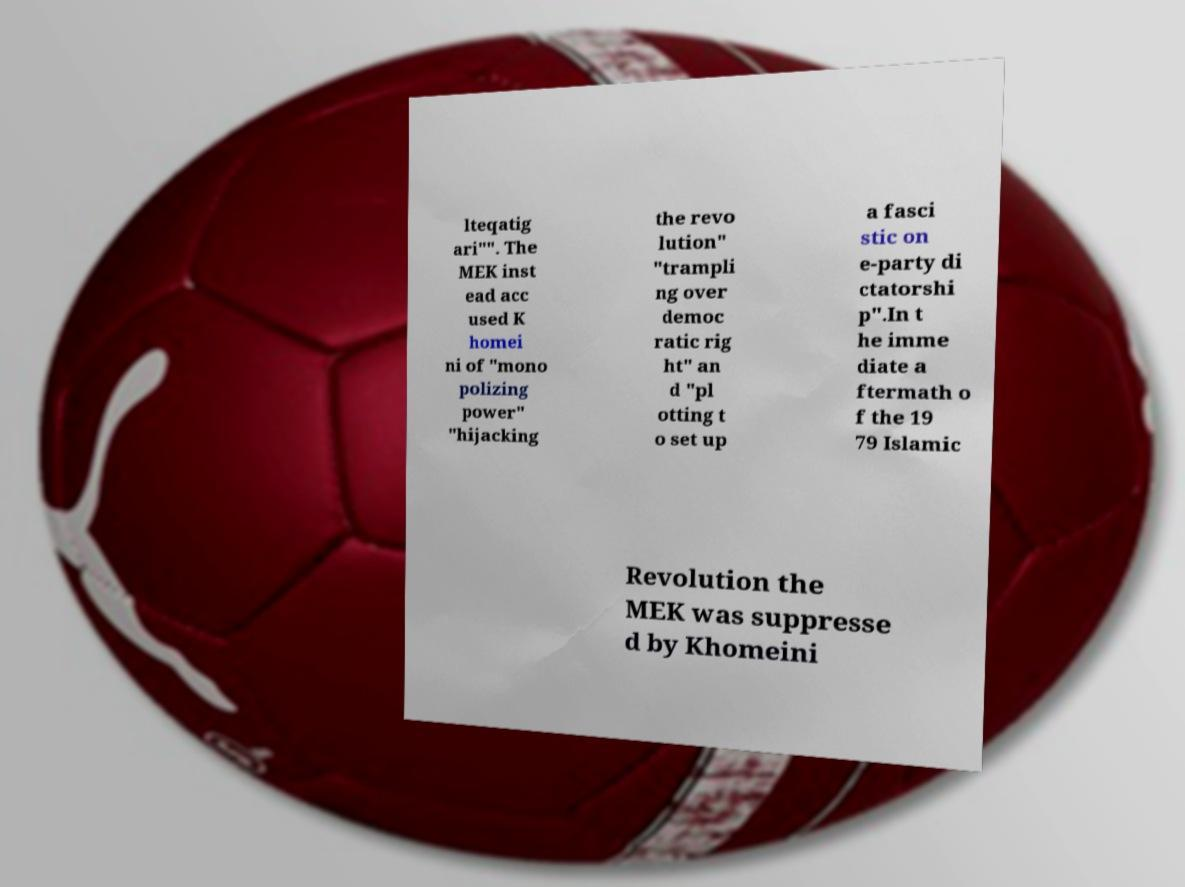What messages or text are displayed in this image? I need them in a readable, typed format. lteqatig ari"". The MEK inst ead acc used K homei ni of "mono polizing power" "hijacking the revo lution" "trampli ng over democ ratic rig ht" an d "pl otting t o set up a fasci stic on e-party di ctatorshi p".In t he imme diate a ftermath o f the 19 79 Islamic Revolution the MEK was suppresse d by Khomeini 